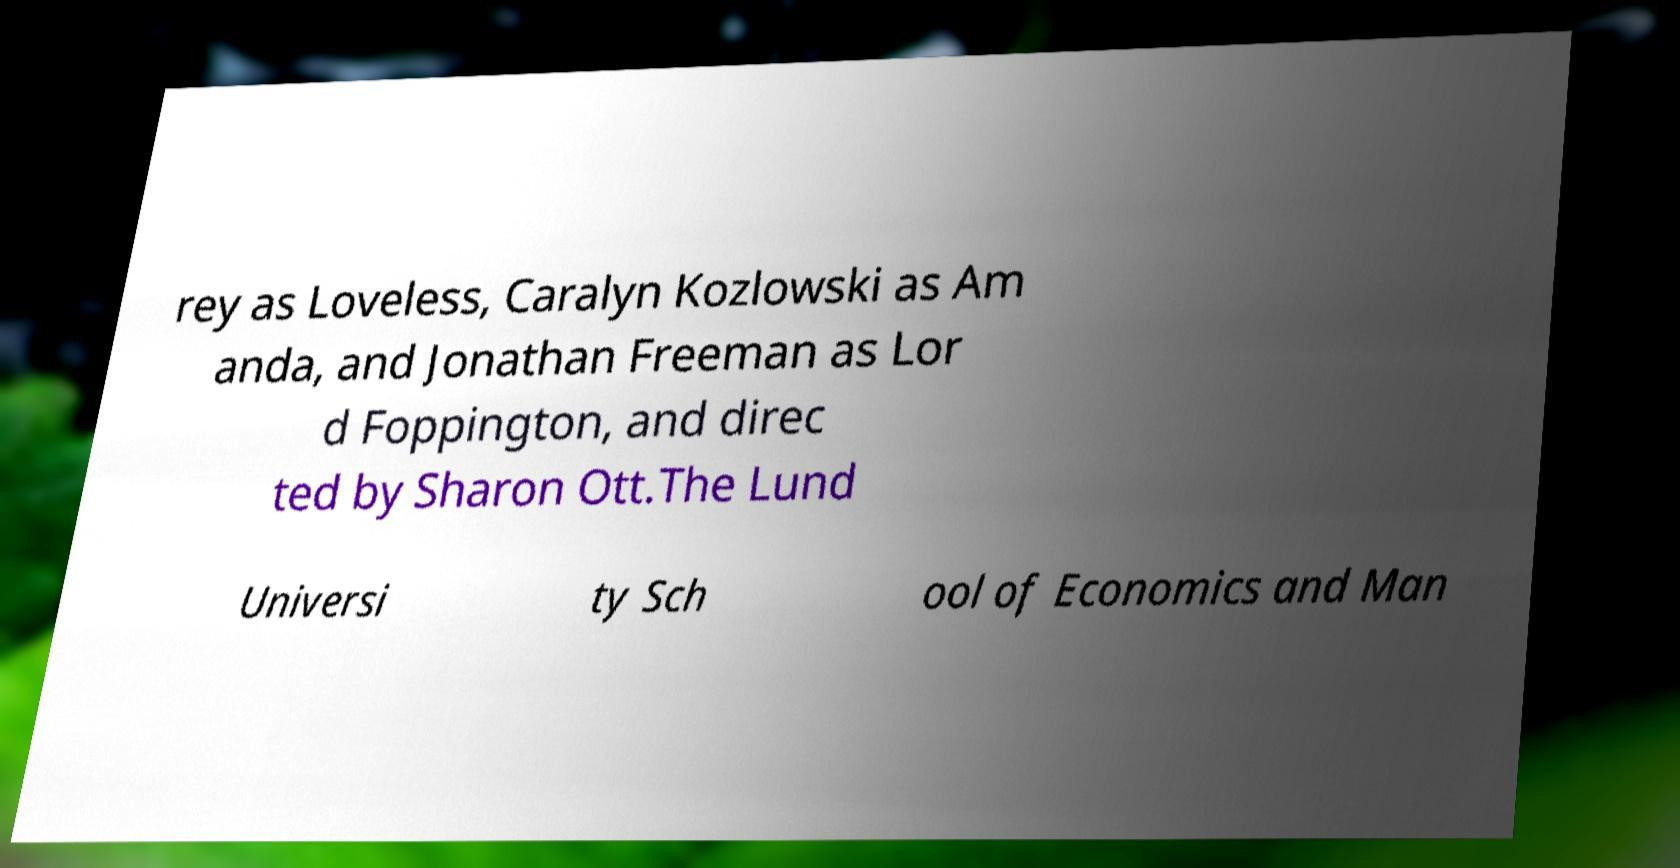Can you accurately transcribe the text from the provided image for me? rey as Loveless, Caralyn Kozlowski as Am anda, and Jonathan Freeman as Lor d Foppington, and direc ted by Sharon Ott.The Lund Universi ty Sch ool of Economics and Man 